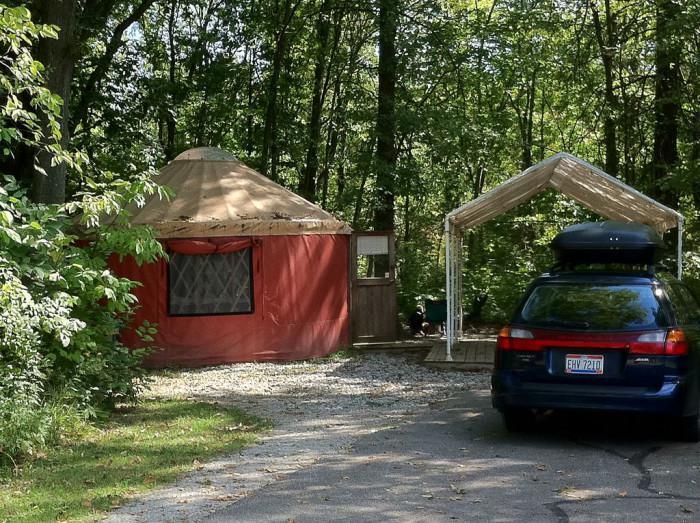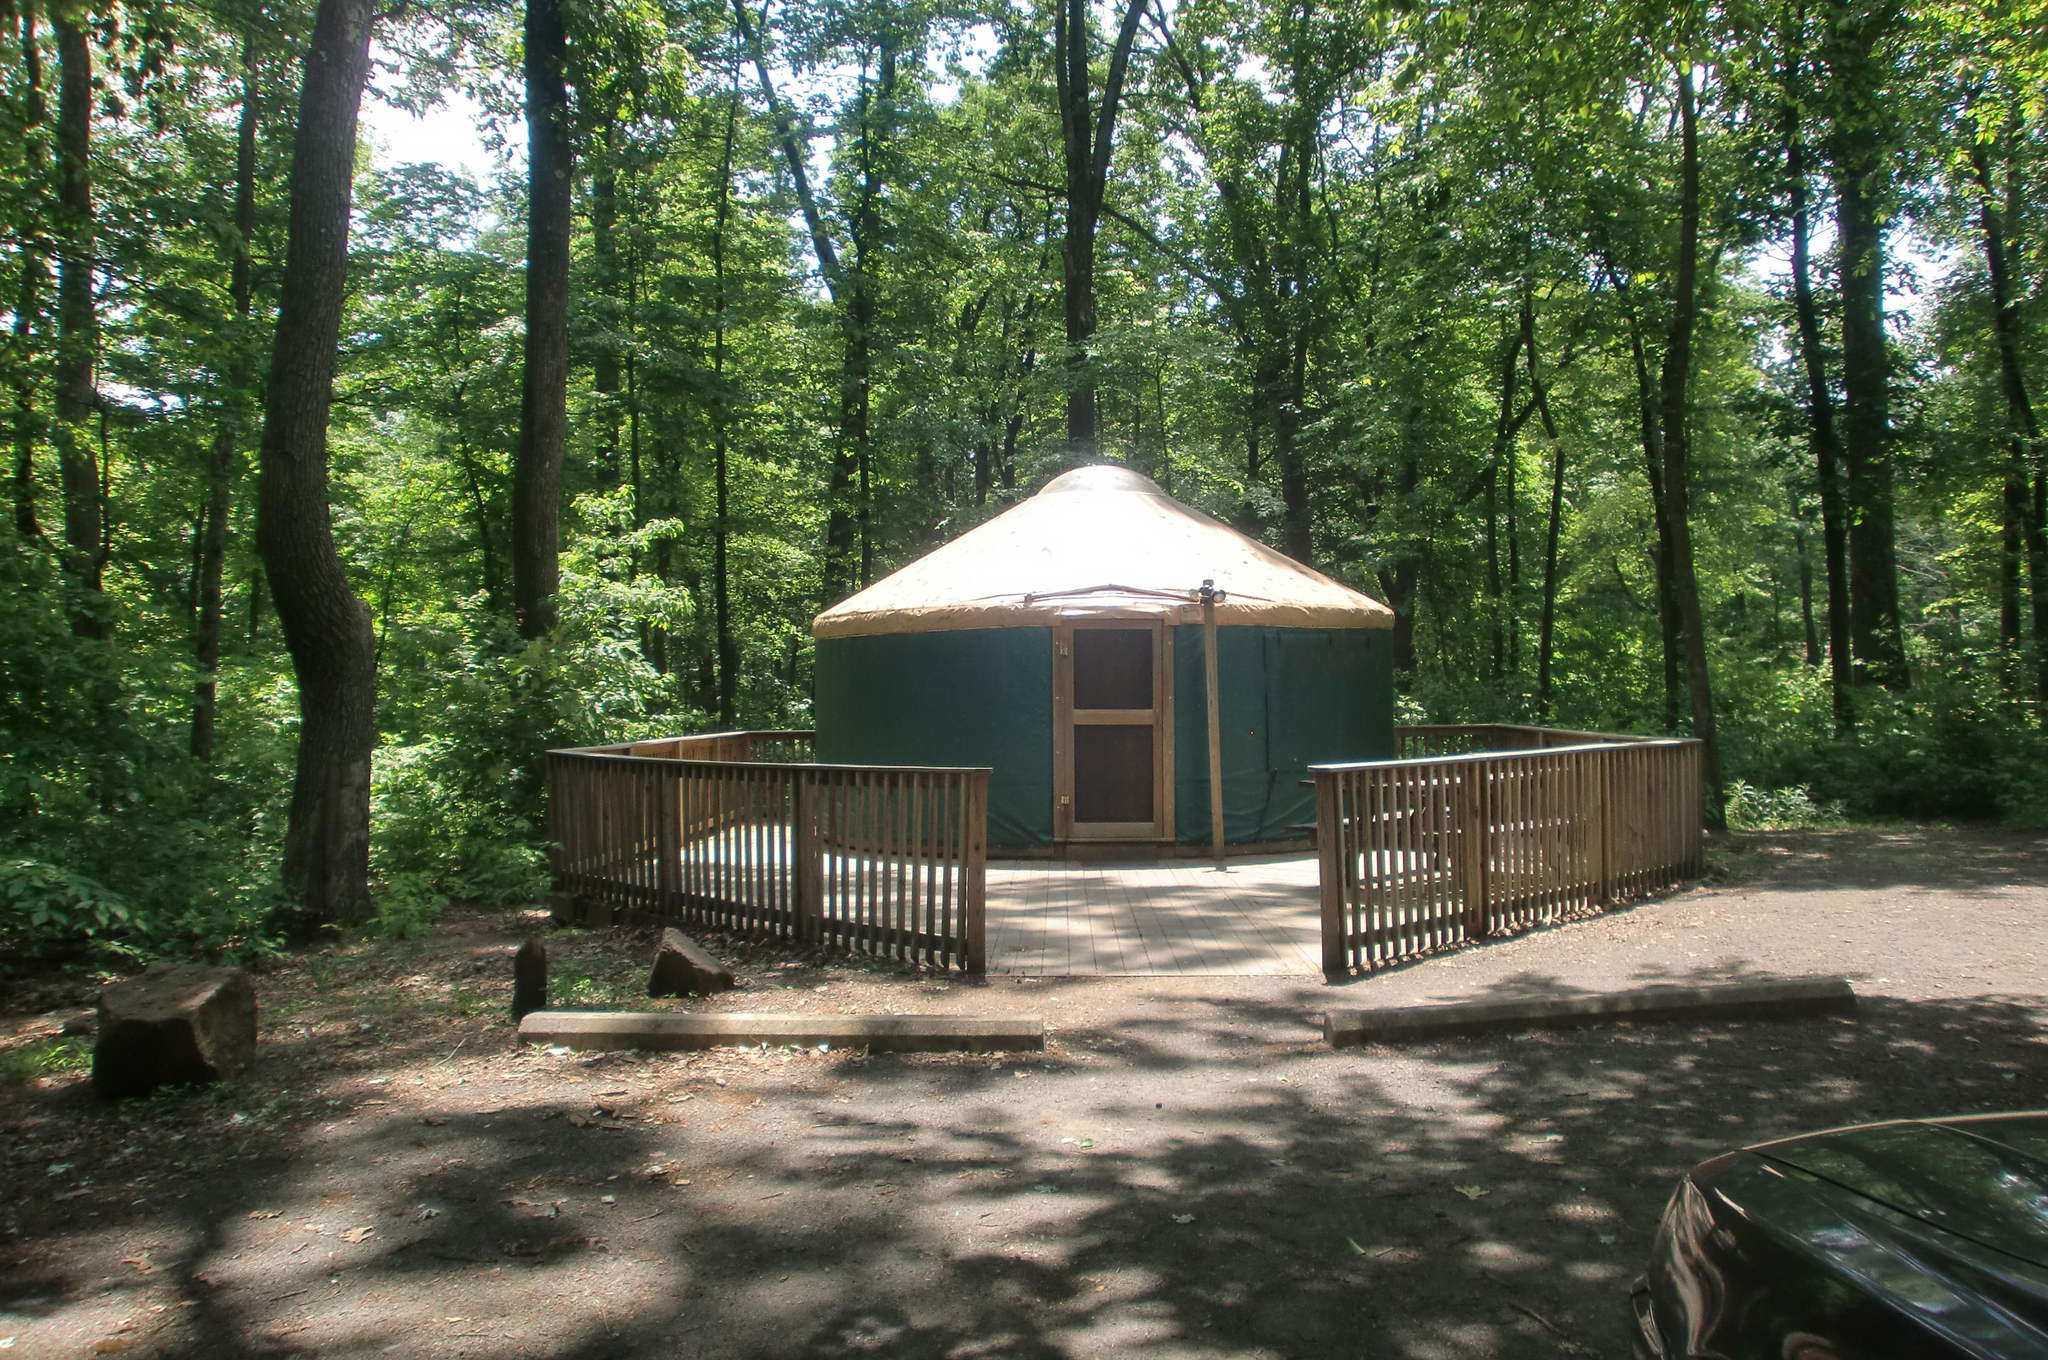The first image is the image on the left, the second image is the image on the right. Analyze the images presented: Is the assertion "A dark green yurt with tan roof is surrounded by a wooden deck with railings, an opening directly in front of the yurt's entry door." valid? Answer yes or no. Yes. The first image is the image on the left, the second image is the image on the right. Considering the images on both sides, is "At least one yurt has a set of three or four wooden stairs that leads to the door." valid? Answer yes or no. No. 